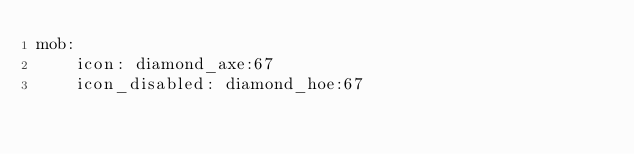<code> <loc_0><loc_0><loc_500><loc_500><_YAML_>mob:
    icon: diamond_axe:67
    icon_disabled: diamond_hoe:67</code> 